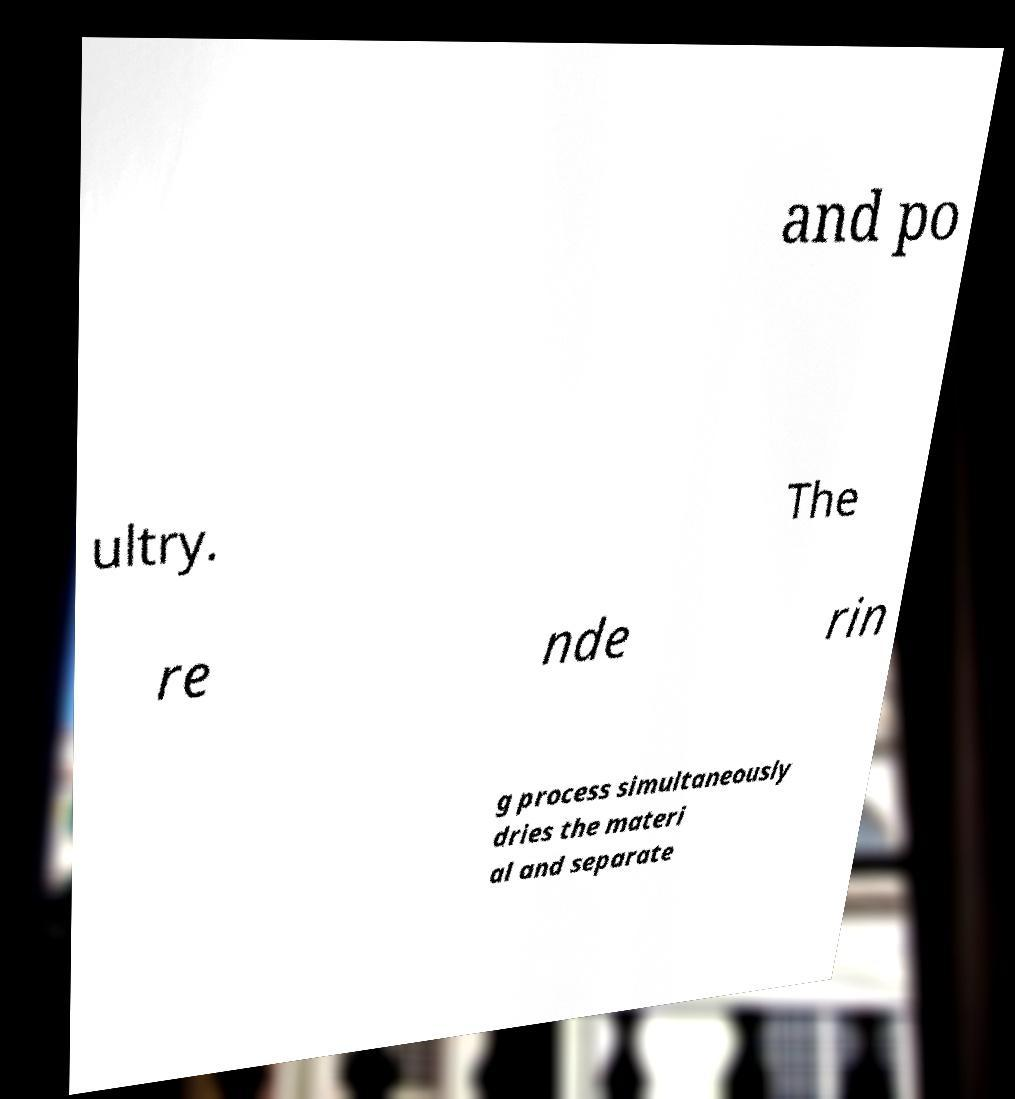Could you extract and type out the text from this image? and po ultry. The re nde rin g process simultaneously dries the materi al and separate 